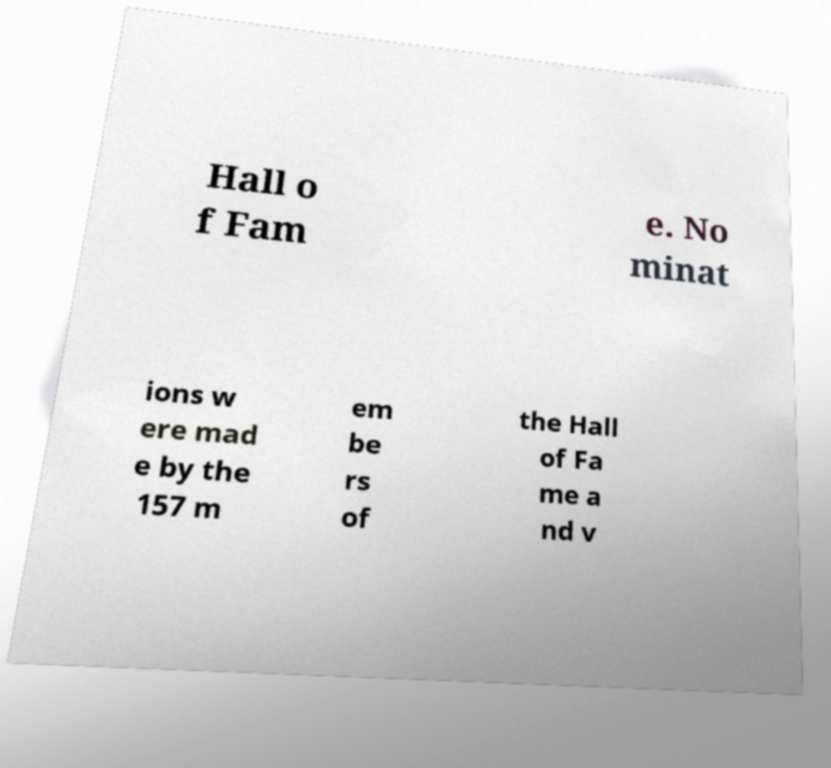For documentation purposes, I need the text within this image transcribed. Could you provide that? Hall o f Fam e. No minat ions w ere mad e by the 157 m em be rs of the Hall of Fa me a nd v 